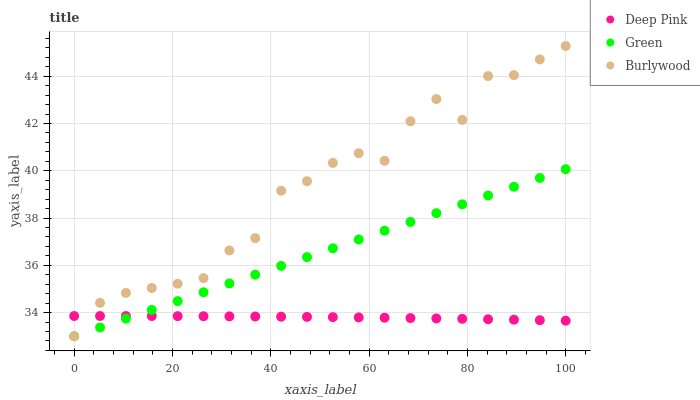Does Deep Pink have the minimum area under the curve?
Answer yes or no. Yes. Does Burlywood have the maximum area under the curve?
Answer yes or no. Yes. Does Green have the minimum area under the curve?
Answer yes or no. No. Does Green have the maximum area under the curve?
Answer yes or no. No. Is Green the smoothest?
Answer yes or no. Yes. Is Burlywood the roughest?
Answer yes or no. Yes. Is Deep Pink the smoothest?
Answer yes or no. No. Is Deep Pink the roughest?
Answer yes or no. No. Does Burlywood have the lowest value?
Answer yes or no. Yes. Does Deep Pink have the lowest value?
Answer yes or no. No. Does Burlywood have the highest value?
Answer yes or no. Yes. Does Green have the highest value?
Answer yes or no. No. Does Deep Pink intersect Green?
Answer yes or no. Yes. Is Deep Pink less than Green?
Answer yes or no. No. Is Deep Pink greater than Green?
Answer yes or no. No. 